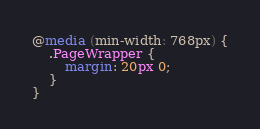Convert code to text. <code><loc_0><loc_0><loc_500><loc_500><_CSS_>@media (min-width: 768px) {
	.PageWrapper {
		margin: 20px 0;
	}
}
</code> 